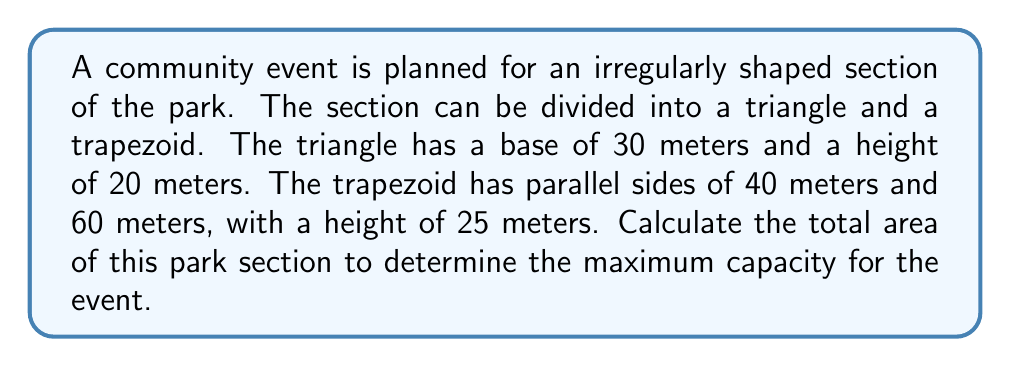Help me with this question. To find the total area of the irregularly shaped park section, we need to calculate the areas of the triangle and trapezoid separately, then add them together.

1. Area of the triangle:
   The formula for the area of a triangle is:
   $$A_{triangle} = \frac{1}{2} \times base \times height$$
   
   Substituting the given values:
   $$A_{triangle} = \frac{1}{2} \times 30 \times 20 = 300 \text{ m}^2$$

2. Area of the trapezoid:
   The formula for the area of a trapezoid is:
   $$A_{trapezoid} = \frac{1}{2}(a+b)h$$
   where $a$ and $b$ are the parallel sides and $h$ is the height.
   
   Substituting the given values:
   $$A_{trapezoid} = \frac{1}{2}(40+60) \times 25 = \frac{1}{2} \times 100 \times 25 = 1250 \text{ m}^2$$

3. Total area:
   The total area is the sum of the triangle and trapezoid areas:
   $$A_{total} = A_{triangle} + A_{trapezoid} = 300 + 1250 = 1550 \text{ m}^2$$

Therefore, the total area of the irregularly shaped park section is 1550 square meters.
Answer: 1550 m² 